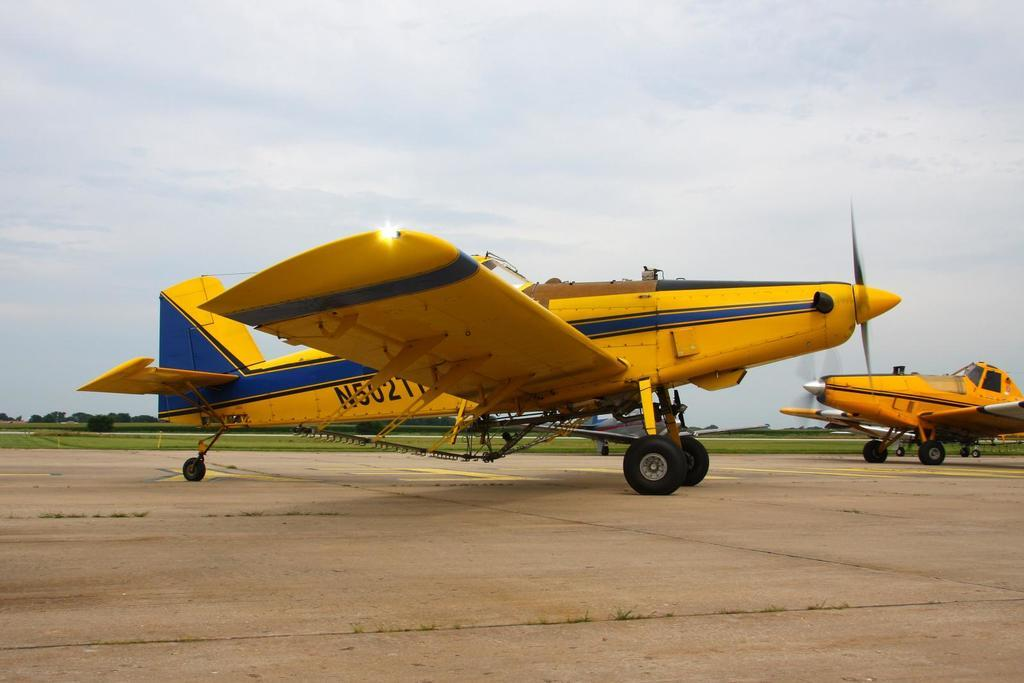Provide a one-sentence caption for the provided image. An airplane whose call number starts with N5 sits on the runway. 